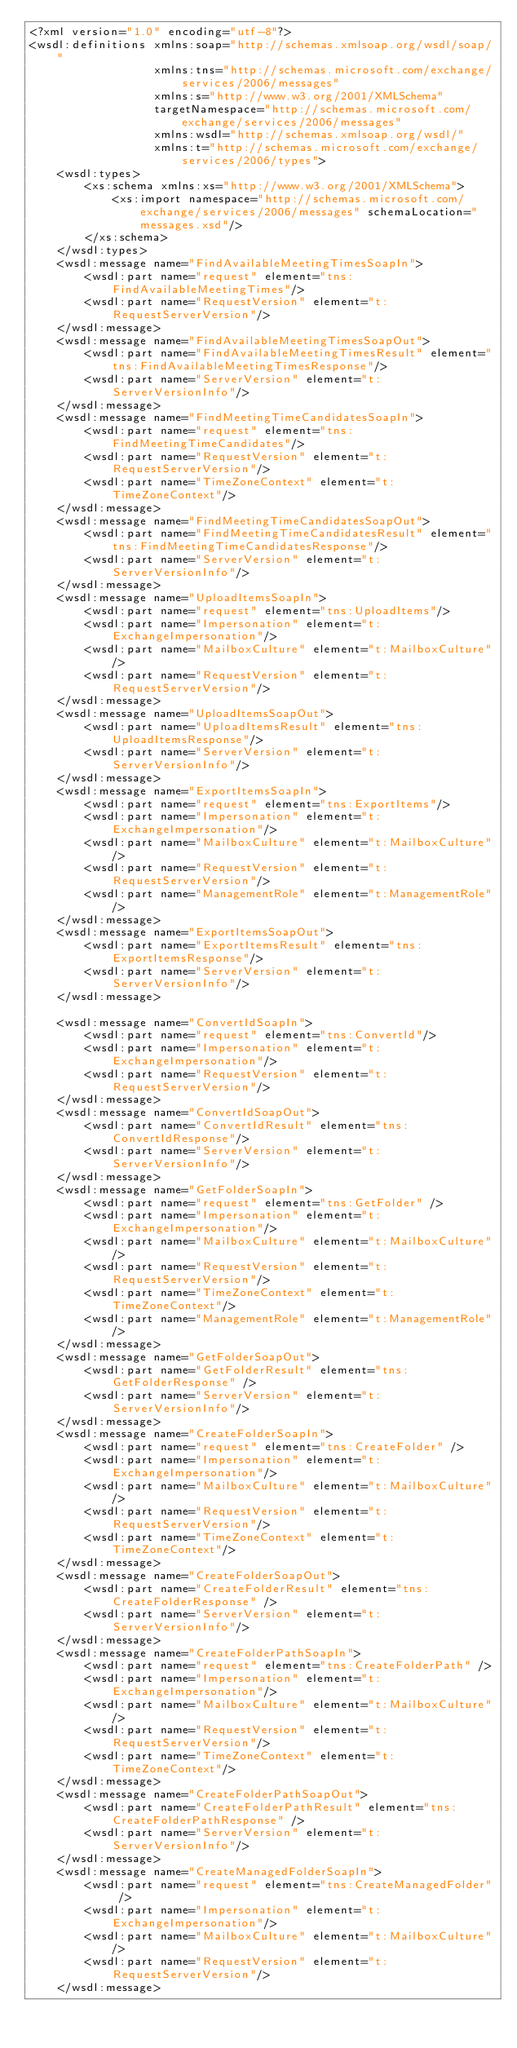Convert code to text. <code><loc_0><loc_0><loc_500><loc_500><_XML_><?xml version="1.0" encoding="utf-8"?>
<wsdl:definitions xmlns:soap="http://schemas.xmlsoap.org/wsdl/soap/"
                  xmlns:tns="http://schemas.microsoft.com/exchange/services/2006/messages"
                  xmlns:s="http://www.w3.org/2001/XMLSchema"
                  targetNamespace="http://schemas.microsoft.com/exchange/services/2006/messages"
                  xmlns:wsdl="http://schemas.xmlsoap.org/wsdl/"
                  xmlns:t="http://schemas.microsoft.com/exchange/services/2006/types">
    <wsdl:types>
        <xs:schema xmlns:xs="http://www.w3.org/2001/XMLSchema">
            <xs:import namespace="http://schemas.microsoft.com/exchange/services/2006/messages" schemaLocation="messages.xsd"/>
        </xs:schema>
    </wsdl:types>
    <wsdl:message name="FindAvailableMeetingTimesSoapIn">
        <wsdl:part name="request" element="tns:FindAvailableMeetingTimes"/>
        <wsdl:part name="RequestVersion" element="t:RequestServerVersion"/>
    </wsdl:message>
    <wsdl:message name="FindAvailableMeetingTimesSoapOut">
        <wsdl:part name="FindAvailableMeetingTimesResult" element="tns:FindAvailableMeetingTimesResponse"/>
        <wsdl:part name="ServerVersion" element="t:ServerVersionInfo"/>
    </wsdl:message>
    <wsdl:message name="FindMeetingTimeCandidatesSoapIn">
        <wsdl:part name="request" element="tns:FindMeetingTimeCandidates"/>
        <wsdl:part name="RequestVersion" element="t:RequestServerVersion"/>
        <wsdl:part name="TimeZoneContext" element="t:TimeZoneContext"/>
    </wsdl:message>
    <wsdl:message name="FindMeetingTimeCandidatesSoapOut">
        <wsdl:part name="FindMeetingTimeCandidatesResult" element="tns:FindMeetingTimeCandidatesResponse"/>
        <wsdl:part name="ServerVersion" element="t:ServerVersionInfo"/>
    </wsdl:message>
    <wsdl:message name="UploadItemsSoapIn">
        <wsdl:part name="request" element="tns:UploadItems"/>
        <wsdl:part name="Impersonation" element="t:ExchangeImpersonation"/>
        <wsdl:part name="MailboxCulture" element="t:MailboxCulture"/>
        <wsdl:part name="RequestVersion" element="t:RequestServerVersion"/>
    </wsdl:message>
    <wsdl:message name="UploadItemsSoapOut">
        <wsdl:part name="UploadItemsResult" element="tns:UploadItemsResponse"/>
        <wsdl:part name="ServerVersion" element="t:ServerVersionInfo"/>
    </wsdl:message>
    <wsdl:message name="ExportItemsSoapIn">
        <wsdl:part name="request" element="tns:ExportItems"/>
        <wsdl:part name="Impersonation" element="t:ExchangeImpersonation"/>
        <wsdl:part name="MailboxCulture" element="t:MailboxCulture"/>
        <wsdl:part name="RequestVersion" element="t:RequestServerVersion"/>
        <wsdl:part name="ManagementRole" element="t:ManagementRole"/>
    </wsdl:message>
    <wsdl:message name="ExportItemsSoapOut">
        <wsdl:part name="ExportItemsResult" element="tns:ExportItemsResponse"/>
        <wsdl:part name="ServerVersion" element="t:ServerVersionInfo"/>
    </wsdl:message>

    <wsdl:message name="ConvertIdSoapIn">
        <wsdl:part name="request" element="tns:ConvertId"/>
        <wsdl:part name="Impersonation" element="t:ExchangeImpersonation"/>
        <wsdl:part name="RequestVersion" element="t:RequestServerVersion"/>
    </wsdl:message>
    <wsdl:message name="ConvertIdSoapOut">
        <wsdl:part name="ConvertIdResult" element="tns:ConvertIdResponse"/>
        <wsdl:part name="ServerVersion" element="t:ServerVersionInfo"/>
    </wsdl:message>
    <wsdl:message name="GetFolderSoapIn">
        <wsdl:part name="request" element="tns:GetFolder" />
        <wsdl:part name="Impersonation" element="t:ExchangeImpersonation"/>
        <wsdl:part name="MailboxCulture" element="t:MailboxCulture"/>
        <wsdl:part name="RequestVersion" element="t:RequestServerVersion"/>
        <wsdl:part name="TimeZoneContext" element="t:TimeZoneContext"/>
        <wsdl:part name="ManagementRole" element="t:ManagementRole"/>
    </wsdl:message>
    <wsdl:message name="GetFolderSoapOut">
        <wsdl:part name="GetFolderResult" element="tns:GetFolderResponse" />
        <wsdl:part name="ServerVersion" element="t:ServerVersionInfo"/>
    </wsdl:message>
    <wsdl:message name="CreateFolderSoapIn">
        <wsdl:part name="request" element="tns:CreateFolder" />
        <wsdl:part name="Impersonation" element="t:ExchangeImpersonation"/>
        <wsdl:part name="MailboxCulture" element="t:MailboxCulture"/>
        <wsdl:part name="RequestVersion" element="t:RequestServerVersion"/>
        <wsdl:part name="TimeZoneContext" element="t:TimeZoneContext"/>
    </wsdl:message>
    <wsdl:message name="CreateFolderSoapOut">
        <wsdl:part name="CreateFolderResult" element="tns:CreateFolderResponse" />
        <wsdl:part name="ServerVersion" element="t:ServerVersionInfo"/>
    </wsdl:message>
    <wsdl:message name="CreateFolderPathSoapIn">
        <wsdl:part name="request" element="tns:CreateFolderPath" />
        <wsdl:part name="Impersonation" element="t:ExchangeImpersonation"/>
        <wsdl:part name="MailboxCulture" element="t:MailboxCulture"/>
        <wsdl:part name="RequestVersion" element="t:RequestServerVersion"/>
        <wsdl:part name="TimeZoneContext" element="t:TimeZoneContext"/>
    </wsdl:message>
    <wsdl:message name="CreateFolderPathSoapOut">
        <wsdl:part name="CreateFolderPathResult" element="tns:CreateFolderPathResponse" />
        <wsdl:part name="ServerVersion" element="t:ServerVersionInfo"/>
    </wsdl:message>
    <wsdl:message name="CreateManagedFolderSoapIn">
        <wsdl:part name="request" element="tns:CreateManagedFolder" />
        <wsdl:part name="Impersonation" element="t:ExchangeImpersonation"/>
        <wsdl:part name="MailboxCulture" element="t:MailboxCulture"/>
        <wsdl:part name="RequestVersion" element="t:RequestServerVersion"/>
    </wsdl:message></code> 